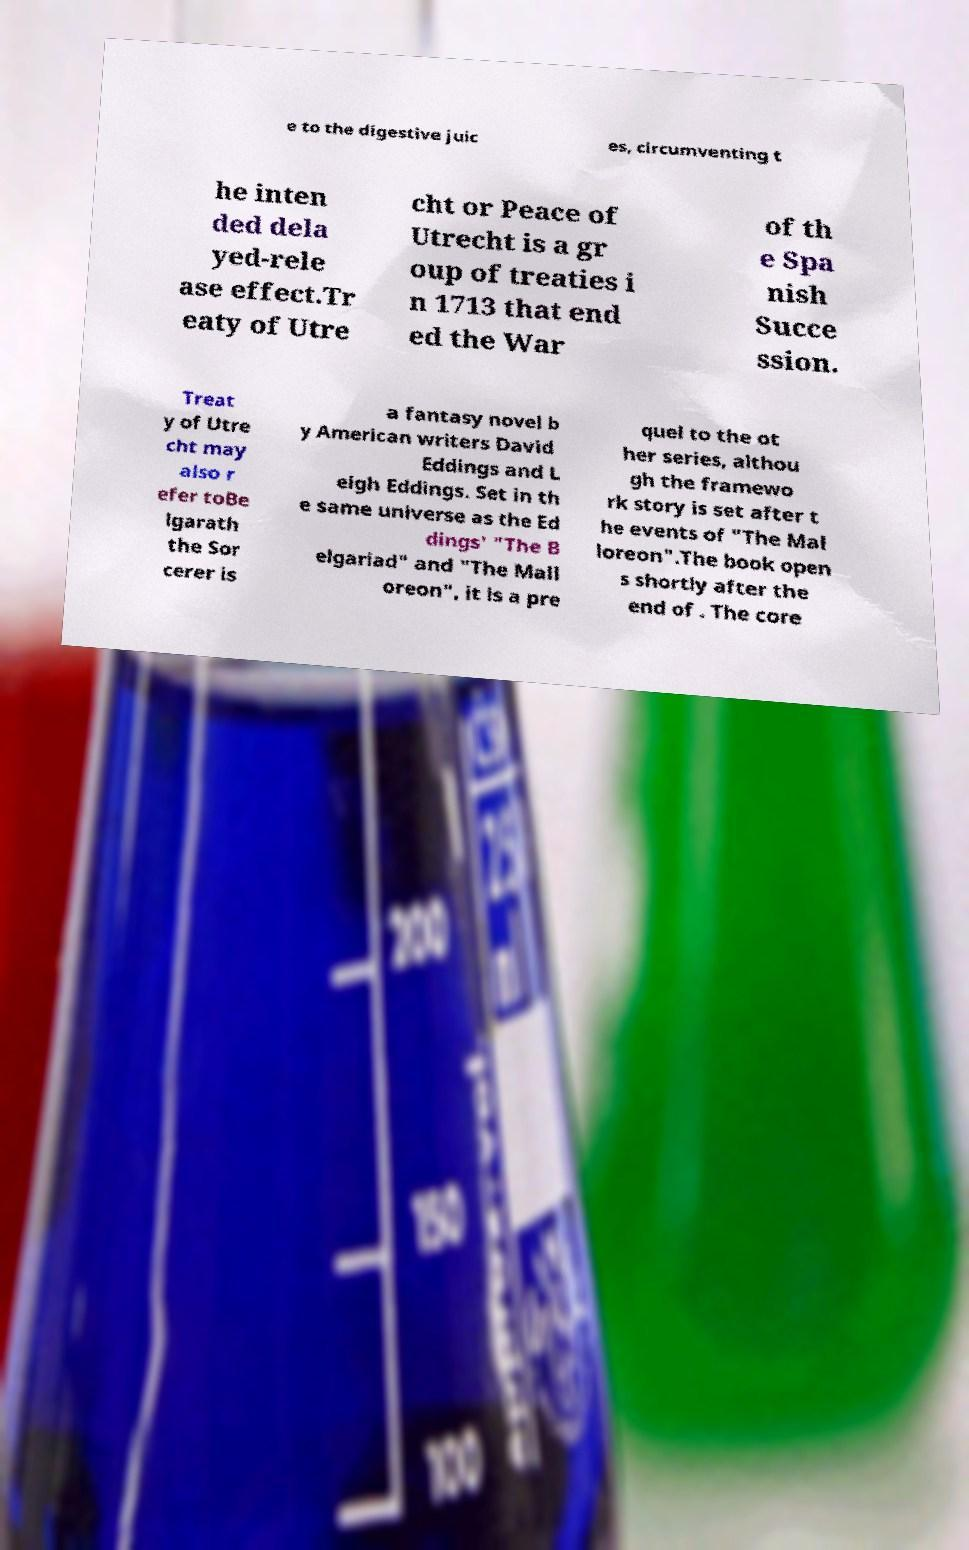Could you extract and type out the text from this image? e to the digestive juic es, circumventing t he inten ded dela yed-rele ase effect.Tr eaty of Utre cht or Peace of Utrecht is a gr oup of treaties i n 1713 that end ed the War of th e Spa nish Succe ssion. Treat y of Utre cht may also r efer toBe lgarath the Sor cerer is a fantasy novel b y American writers David Eddings and L eigh Eddings. Set in th e same universe as the Ed dings' "The B elgariad" and "The Mall oreon", it is a pre quel to the ot her series, althou gh the framewo rk story is set after t he events of "The Mal loreon".The book open s shortly after the end of . The core 